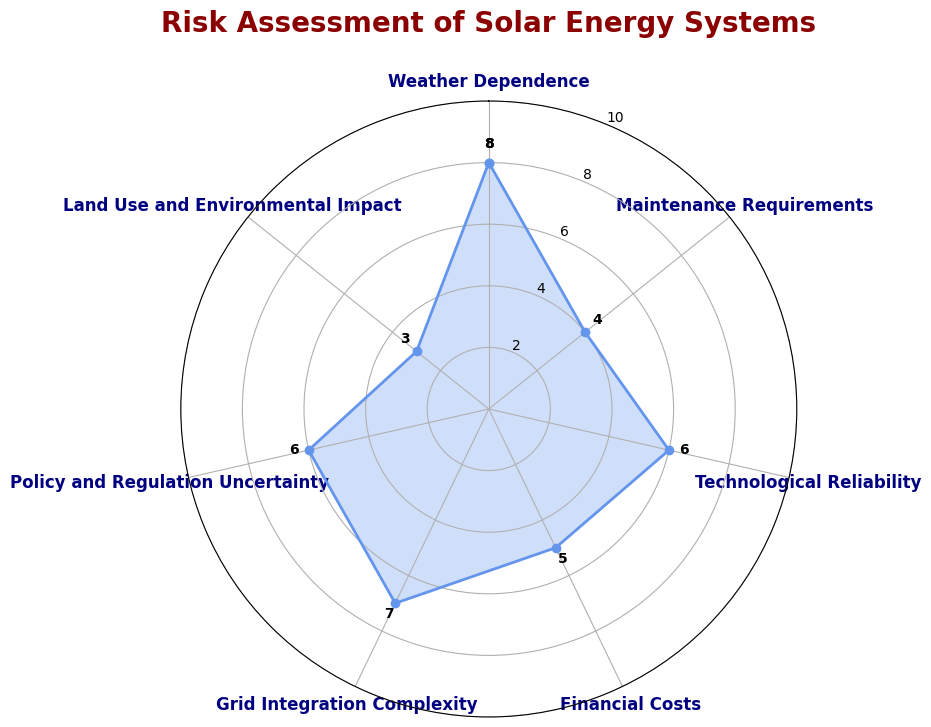What's the highest risk factor in the assessment? The highest risk factor can be identified as the one with the highest value in the radar chart. In this case, 'Weather Dependence' has the highest value at 8.
Answer: Weather Dependence Which two risk factors have the same value, and what is their value? By looking at the values on the radar chart, 'Technological Reliability' and 'Policy and Regulation Uncertainty' both have a value of 6.
Answer: Technological Reliability and Policy and Regulation Uncertainty, 6 What is the difference between the highest and lowest risk factors? The highest value is 8 (Weather Dependence) and the lowest value is 3 (Land Use and Environmental Impact). The difference is 8 - 3 = 5.
Answer: 5 What are the risk factors that are greater than or equal to 6? By checking the radar chart, the risk factors with values greater than or equal to 6 are 'Weather Dependence' (8), 'Technological Reliability' (6), 'Grid Integration Complexity' (7), and 'Policy and Regulation Uncertainty' (6).
Answer: Weather Dependence, Technological Reliability, Grid Integration Complexity, Policy and Regulation Uncertainty Which category has the least risk, and what is its value? The radar chart shows that 'Land Use and Environmental Impact' has the lowest value of 3.
Answer: Land Use and Environmental Impact, 3 Calculate the average value of all the risk factors. To find the average, sum all the values and divide by the number of risk factors: (8 + 4 + 6 + 5 + 7 + 6 + 3)/7 = 39/7 ≈ 5.57.
Answer: 5.57 Compare the values of 'Maintenance Requirements' and 'Financial Costs'. Which one is higher and by how much? 'Maintenance Requirements' has a value of 4 and 'Financial Costs' has a value of 5. The difference is 5 - 4 = 1, so 'Financial Costs' is higher by 1.
Answer: Financial Costs, 1 What is the sum of 'Grid Integration Complexity' and 'Land Use and Environmental Impact'? The values are 7 for 'Grid Integration Complexity' and 3 for 'Land Use and Environmental Impact'. Their sum is 7 + 3 = 10.
Answer: 10 What is the range of the risk values? The range is calculated by subtracting the smallest value from the largest value: 8 (Weather Dependence) - 3 (Land Use and Environmental Impact) = 5.
Answer: 5 Which risk factors are lower than 5? From the radar chart, 'Maintenance Requirements' (4) and 'Land Use and Environmental Impact' (3) have values lower than 5.
Answer: Maintenance Requirements and Land Use and Environmental Impact 